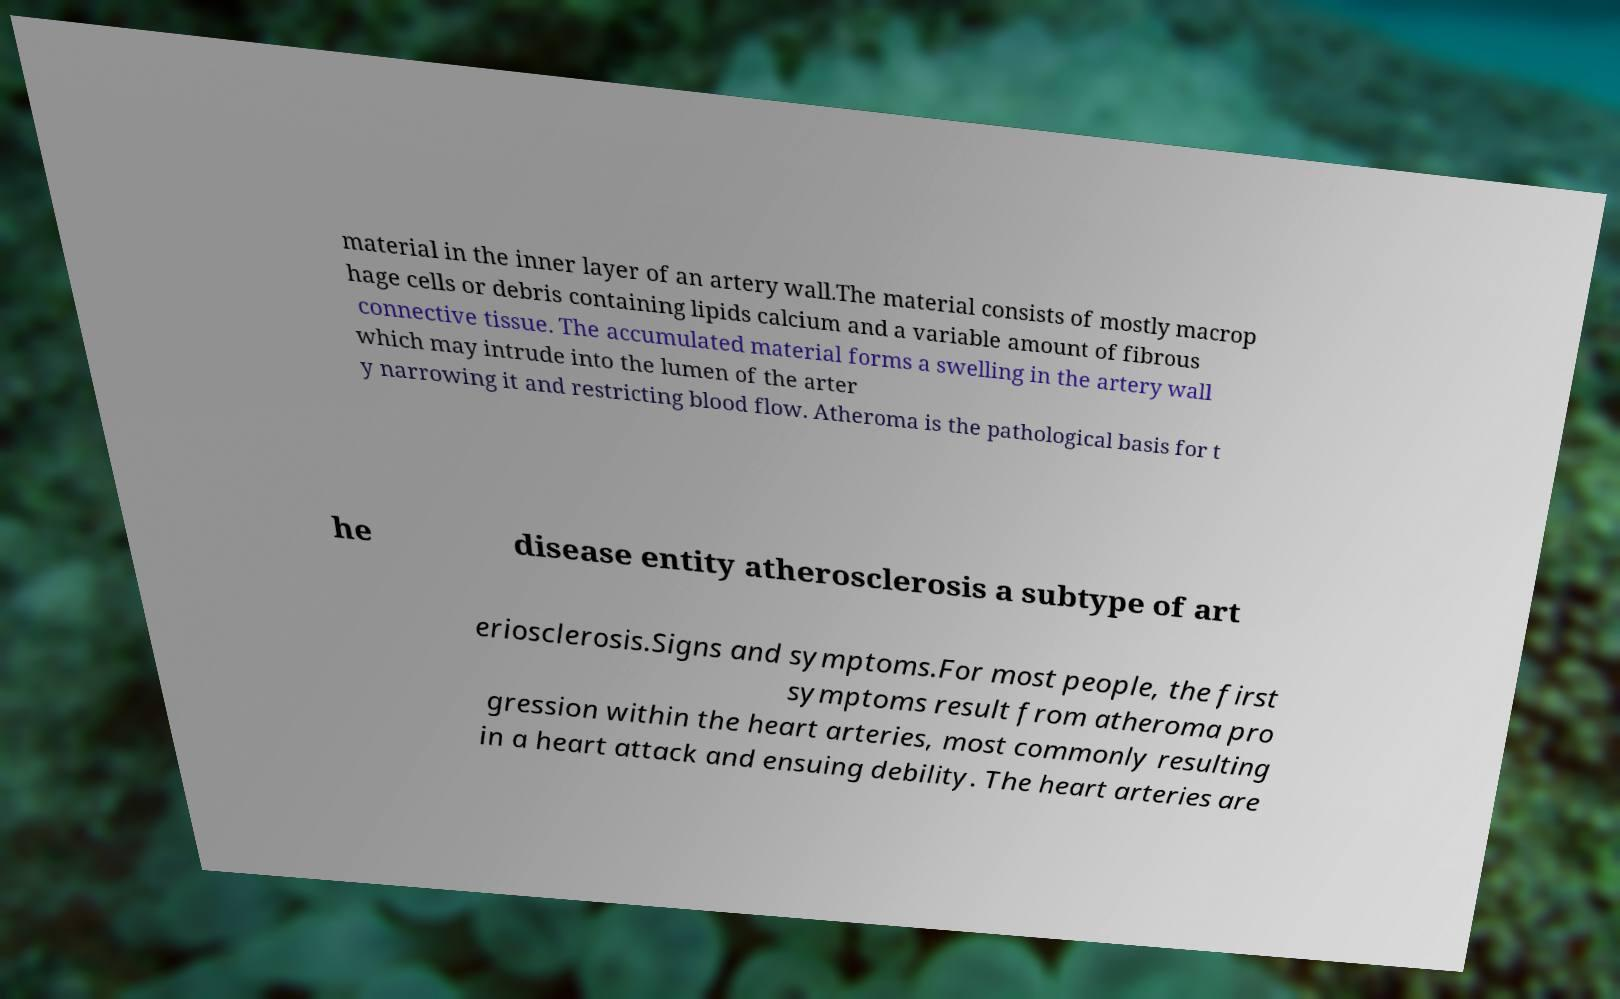There's text embedded in this image that I need extracted. Can you transcribe it verbatim? material in the inner layer of an artery wall.The material consists of mostly macrop hage cells or debris containing lipids calcium and a variable amount of fibrous connective tissue. The accumulated material forms a swelling in the artery wall which may intrude into the lumen of the arter y narrowing it and restricting blood flow. Atheroma is the pathological basis for t he disease entity atherosclerosis a subtype of art eriosclerosis.Signs and symptoms.For most people, the first symptoms result from atheroma pro gression within the heart arteries, most commonly resulting in a heart attack and ensuing debility. The heart arteries are 